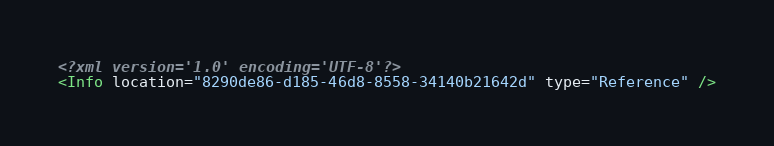<code> <loc_0><loc_0><loc_500><loc_500><_XML_><?xml version='1.0' encoding='UTF-8'?>
<Info location="8290de86-d185-46d8-8558-34140b21642d" type="Reference" /></code> 